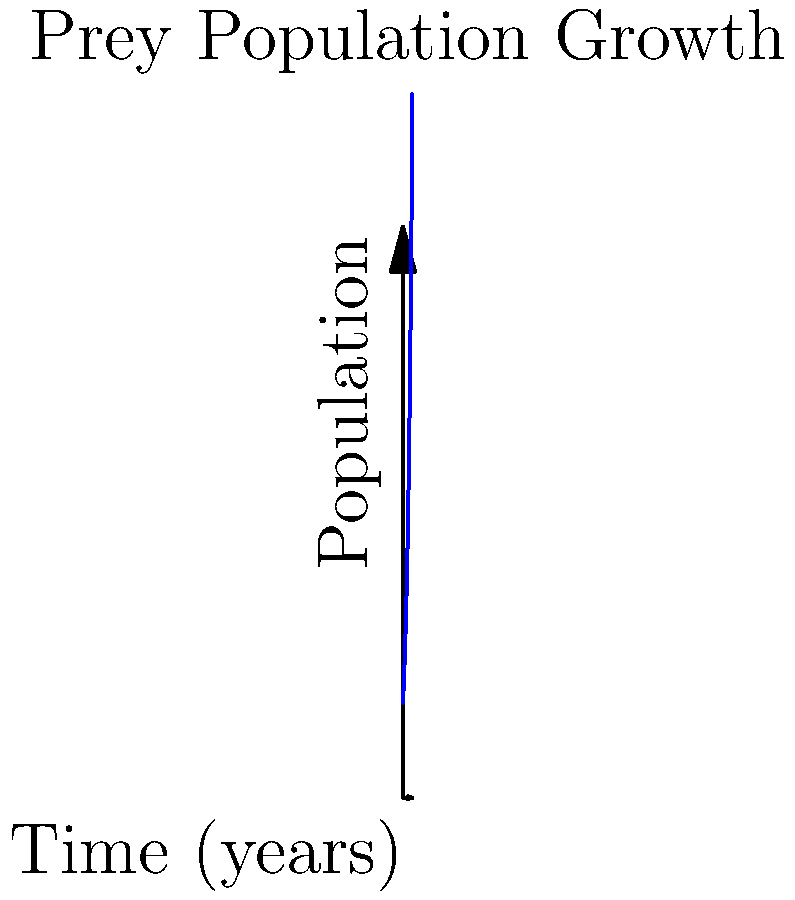As the alpha snow leopard, you're monitoring the population growth of a key prey species in your territory. The graph shows the exponential growth of this prey population over time. If the initial population was 100 individuals, what will be the approximate population after 5 years, assuming the growth rate remains constant? To solve this problem, we need to follow these steps:

1. Identify the exponential growth formula: $P(t) = P_0 e^{rt}$
   Where $P(t)$ is the population at time $t$, $P_0$ is the initial population, $r$ is the growth rate, and $t$ is time.

2. We know:
   - Initial population $P_0 = 100$
   - Time $t = 5$ years

3. From the graph, we can estimate the population at $t = 5$ years to be about 270 individuals.

4. To find the growth rate $r$, we can use the equation:
   $270 \approx 100 e^{5r}$

5. Solving for $r$:
   $\frac{270}{100} \approx e^{5r}$
   $2.7 \approx e^{5r}$
   $\ln(2.7) \approx 5r$
   $r \approx \frac{\ln(2.7)}{5} \approx 0.2$

6. Verify: $P(5) = 100 e^{0.2 * 5} \approx 271$

Therefore, after 5 years, the prey population will be approximately 270 individuals.
Answer: 270 individuals 